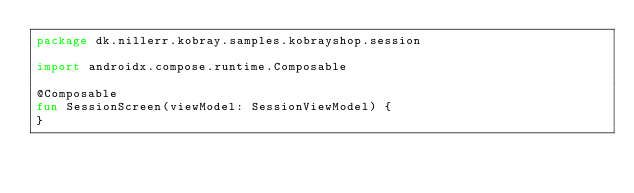Convert code to text. <code><loc_0><loc_0><loc_500><loc_500><_Kotlin_>package dk.nillerr.kobray.samples.kobrayshop.session

import androidx.compose.runtime.Composable

@Composable
fun SessionScreen(viewModel: SessionViewModel) {
}</code> 